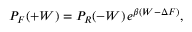<formula> <loc_0><loc_0><loc_500><loc_500>P _ { F } ( + W ) = P _ { R } ( - W ) \, e ^ { \beta ( W - \Delta F ) } ,</formula> 